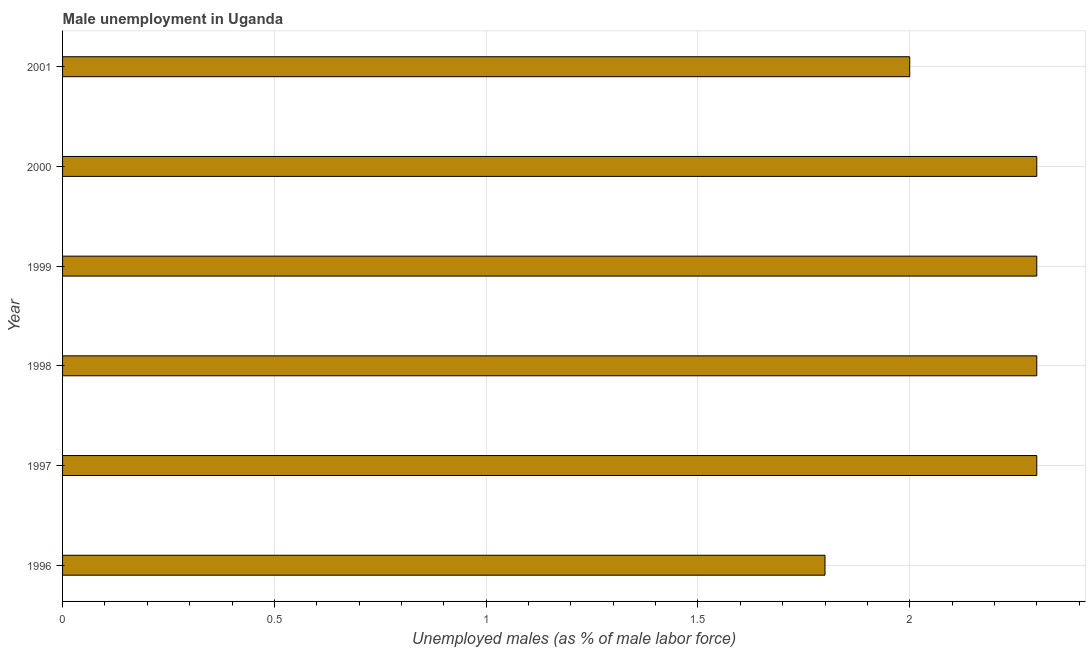Does the graph contain any zero values?
Give a very brief answer. No. What is the title of the graph?
Ensure brevity in your answer.  Male unemployment in Uganda. What is the label or title of the X-axis?
Give a very brief answer. Unemployed males (as % of male labor force). Across all years, what is the maximum unemployed males population?
Offer a very short reply. 2.3. Across all years, what is the minimum unemployed males population?
Make the answer very short. 1.8. What is the sum of the unemployed males population?
Give a very brief answer. 13. What is the average unemployed males population per year?
Your answer should be very brief. 2.17. What is the median unemployed males population?
Your response must be concise. 2.3. In how many years, is the unemployed males population greater than 1.6 %?
Your answer should be very brief. 6. Do a majority of the years between 1997 and 1996 (inclusive) have unemployed males population greater than 2.1 %?
Provide a succinct answer. No. Is the difference between the unemployed males population in 1997 and 2000 greater than the difference between any two years?
Your response must be concise. No. What is the difference between the highest and the second highest unemployed males population?
Your answer should be compact. 0. What is the difference between the highest and the lowest unemployed males population?
Provide a succinct answer. 0.5. Are all the bars in the graph horizontal?
Give a very brief answer. Yes. What is the difference between two consecutive major ticks on the X-axis?
Ensure brevity in your answer.  0.5. What is the Unemployed males (as % of male labor force) in 1996?
Your answer should be very brief. 1.8. What is the Unemployed males (as % of male labor force) of 1997?
Give a very brief answer. 2.3. What is the Unemployed males (as % of male labor force) in 1998?
Give a very brief answer. 2.3. What is the Unemployed males (as % of male labor force) in 1999?
Give a very brief answer. 2.3. What is the Unemployed males (as % of male labor force) of 2000?
Your answer should be compact. 2.3. What is the difference between the Unemployed males (as % of male labor force) in 1996 and 1997?
Keep it short and to the point. -0.5. What is the difference between the Unemployed males (as % of male labor force) in 1996 and 1998?
Your answer should be very brief. -0.5. What is the difference between the Unemployed males (as % of male labor force) in 1996 and 2001?
Make the answer very short. -0.2. What is the difference between the Unemployed males (as % of male labor force) in 1997 and 1999?
Give a very brief answer. 0. What is the difference between the Unemployed males (as % of male labor force) in 1997 and 2000?
Keep it short and to the point. 0. What is the difference between the Unemployed males (as % of male labor force) in 1997 and 2001?
Your answer should be compact. 0.3. What is the difference between the Unemployed males (as % of male labor force) in 1998 and 2000?
Provide a short and direct response. 0. What is the difference between the Unemployed males (as % of male labor force) in 1999 and 2001?
Your response must be concise. 0.3. What is the ratio of the Unemployed males (as % of male labor force) in 1996 to that in 1997?
Provide a succinct answer. 0.78. What is the ratio of the Unemployed males (as % of male labor force) in 1996 to that in 1998?
Give a very brief answer. 0.78. What is the ratio of the Unemployed males (as % of male labor force) in 1996 to that in 1999?
Your answer should be very brief. 0.78. What is the ratio of the Unemployed males (as % of male labor force) in 1996 to that in 2000?
Offer a very short reply. 0.78. What is the ratio of the Unemployed males (as % of male labor force) in 1996 to that in 2001?
Offer a terse response. 0.9. What is the ratio of the Unemployed males (as % of male labor force) in 1997 to that in 1998?
Offer a terse response. 1. What is the ratio of the Unemployed males (as % of male labor force) in 1997 to that in 1999?
Provide a short and direct response. 1. What is the ratio of the Unemployed males (as % of male labor force) in 1997 to that in 2001?
Your response must be concise. 1.15. What is the ratio of the Unemployed males (as % of male labor force) in 1998 to that in 2001?
Your answer should be very brief. 1.15. What is the ratio of the Unemployed males (as % of male labor force) in 1999 to that in 2001?
Provide a short and direct response. 1.15. What is the ratio of the Unemployed males (as % of male labor force) in 2000 to that in 2001?
Your answer should be compact. 1.15. 